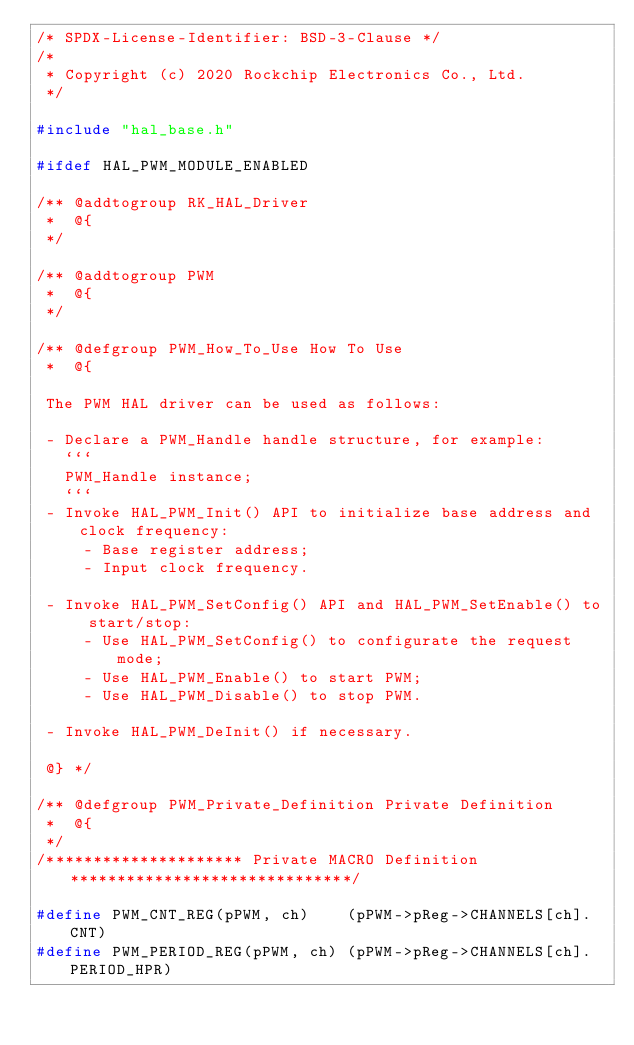Convert code to text. <code><loc_0><loc_0><loc_500><loc_500><_C_>/* SPDX-License-Identifier: BSD-3-Clause */
/*
 * Copyright (c) 2020 Rockchip Electronics Co., Ltd.
 */

#include "hal_base.h"

#ifdef HAL_PWM_MODULE_ENABLED

/** @addtogroup RK_HAL_Driver
 *  @{
 */

/** @addtogroup PWM
 *  @{
 */

/** @defgroup PWM_How_To_Use How To Use
 *  @{

 The PWM HAL driver can be used as follows:

 - Declare a PWM_Handle handle structure, for example:
   ```
   PWM_Handle instance;
   ```
 - Invoke HAL_PWM_Init() API to initialize base address and clock frequency:
     - Base register address;
     - Input clock frequency.

 - Invoke HAL_PWM_SetConfig() API and HAL_PWM_SetEnable() to start/stop:
     - Use HAL_PWM_SetConfig() to configurate the request mode;
     - Use HAL_PWM_Enable() to start PWM;
     - Use HAL_PWM_Disable() to stop PWM.

 - Invoke HAL_PWM_DeInit() if necessary.

 @} */

/** @defgroup PWM_Private_Definition Private Definition
 *  @{
 */
/********************* Private MACRO Definition ******************************/

#define PWM_CNT_REG(pPWM, ch)    (pPWM->pReg->CHANNELS[ch].CNT)
#define PWM_PERIOD_REG(pPWM, ch) (pPWM->pReg->CHANNELS[ch].PERIOD_HPR)</code> 